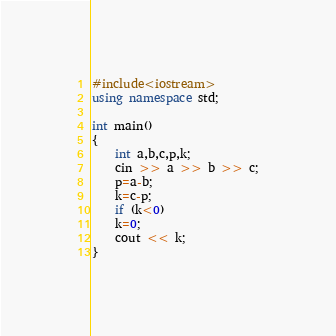<code> <loc_0><loc_0><loc_500><loc_500><_C++_>#include<iostream>
using namespace std;

int main()
{
	int a,b,c,p,k;
	cin >> a >> b >> c;
	p=a-b;
	k=c-p;
	if (k<0)
	k=0;
	cout << k;
}
</code> 